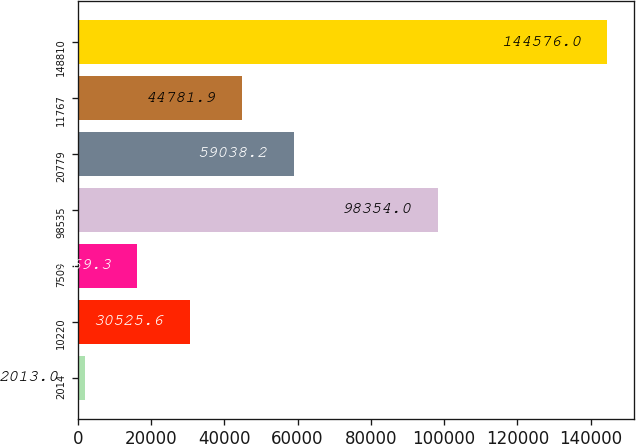Convert chart. <chart><loc_0><loc_0><loc_500><loc_500><bar_chart><fcel>2014<fcel>10220<fcel>7509<fcel>98535<fcel>20779<fcel>11767<fcel>148810<nl><fcel>2013<fcel>30525.6<fcel>16269.3<fcel>98354<fcel>59038.2<fcel>44781.9<fcel>144576<nl></chart> 